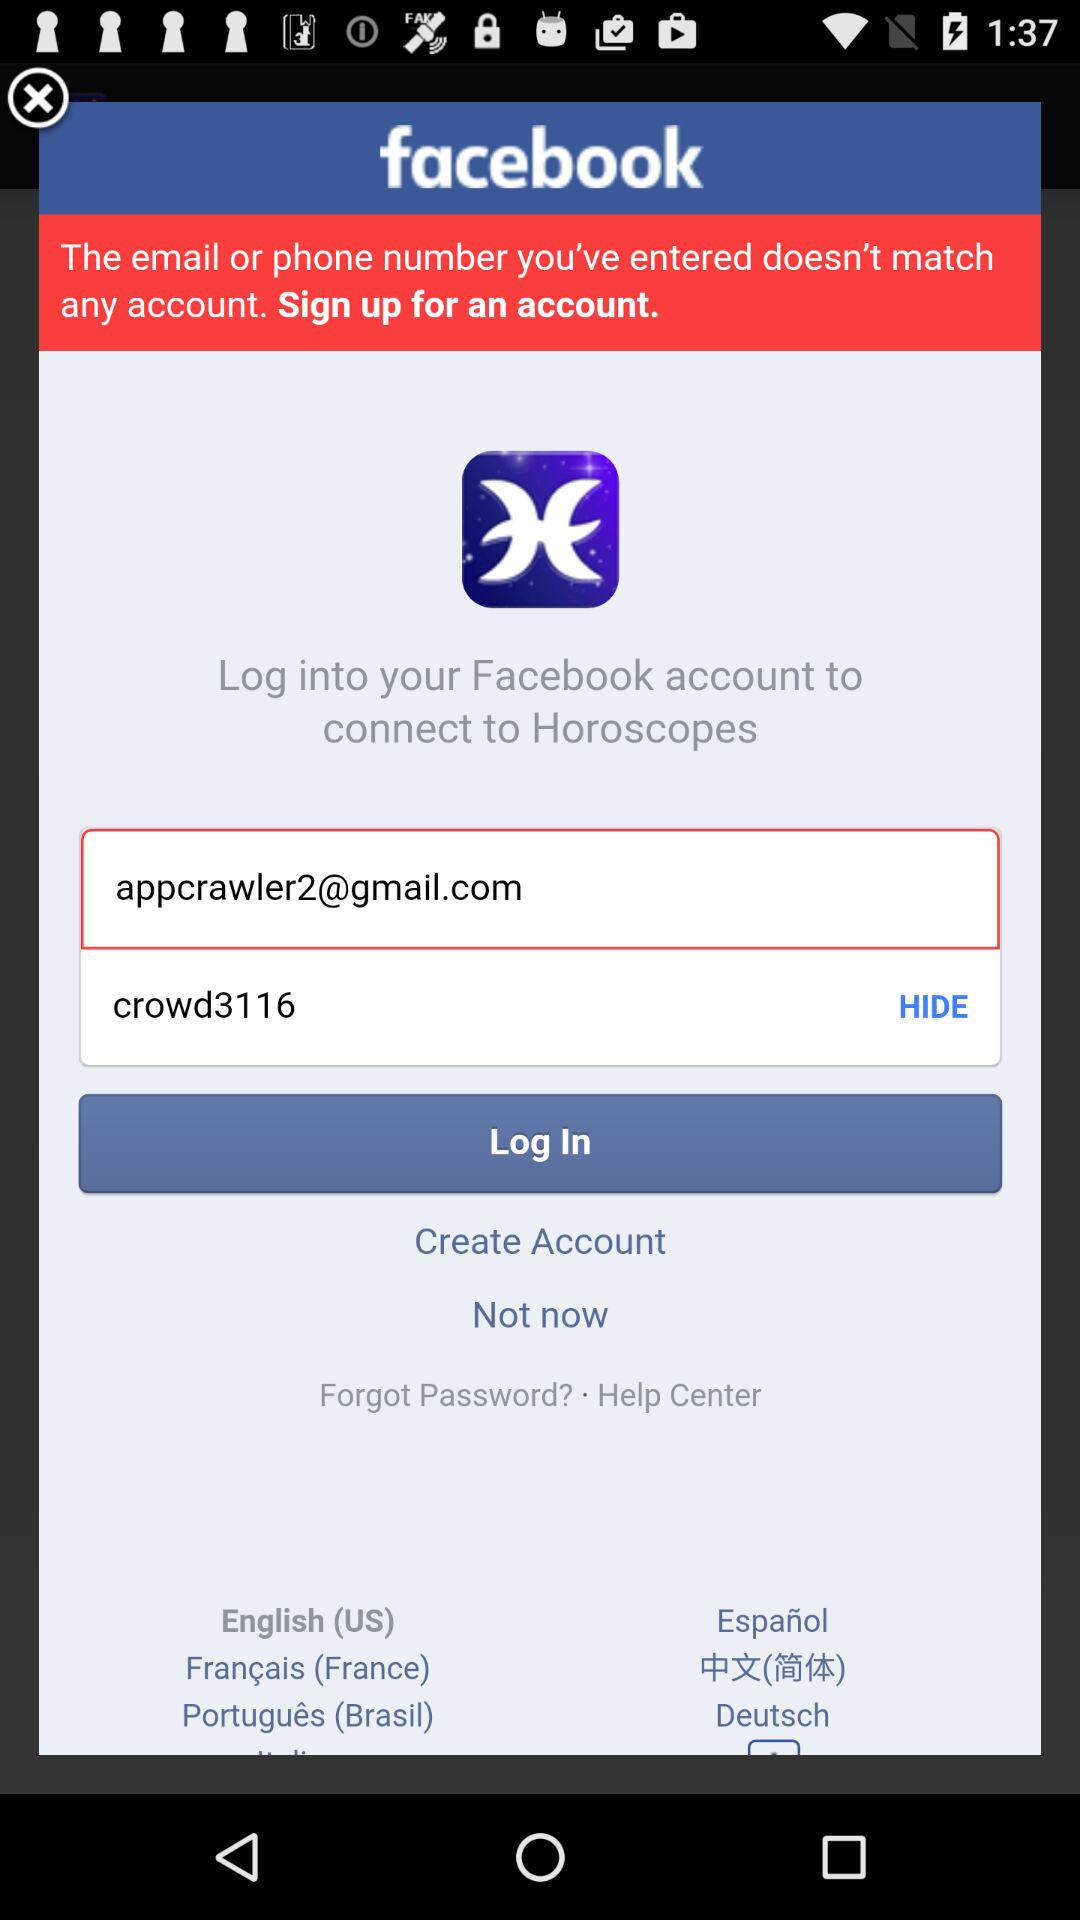How many languages are available on this screen?
Answer the question using a single word or phrase. 6 